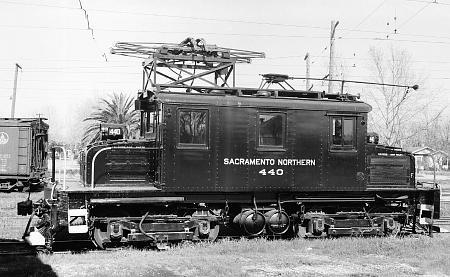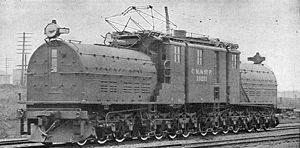The first image is the image on the left, the second image is the image on the right. Given the left and right images, does the statement "There are no humans in the images." hold true? Answer yes or no. Yes. The first image is the image on the left, the second image is the image on the right. Evaluate the accuracy of this statement regarding the images: "Multiple people are standing in the lefthand vintage train image, and the right image shows a leftward-headed train.". Is it true? Answer yes or no. No. 